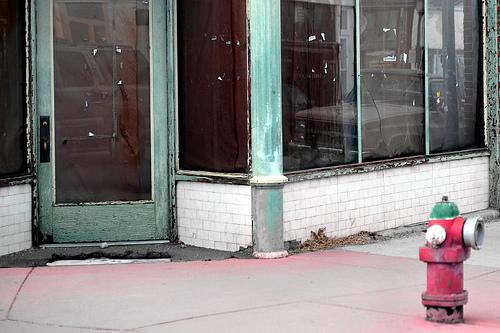What is the hydrant for?
Concise answer only. Water. What color is the fire hydrant on the right?
Write a very short answer. Red. What color is the fire hydrant?
Concise answer only. Red. 